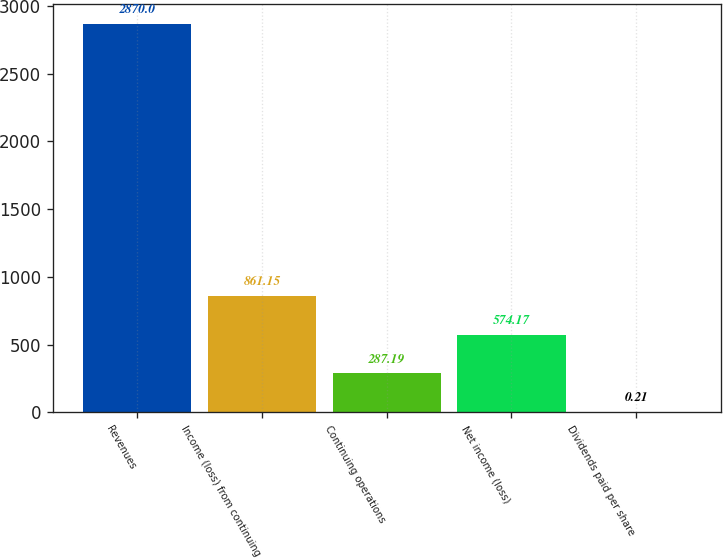Convert chart. <chart><loc_0><loc_0><loc_500><loc_500><bar_chart><fcel>Revenues<fcel>Income (loss) from continuing<fcel>Continuing operations<fcel>Net income (loss)<fcel>Dividends paid per share<nl><fcel>2870<fcel>861.15<fcel>287.19<fcel>574.17<fcel>0.21<nl></chart> 